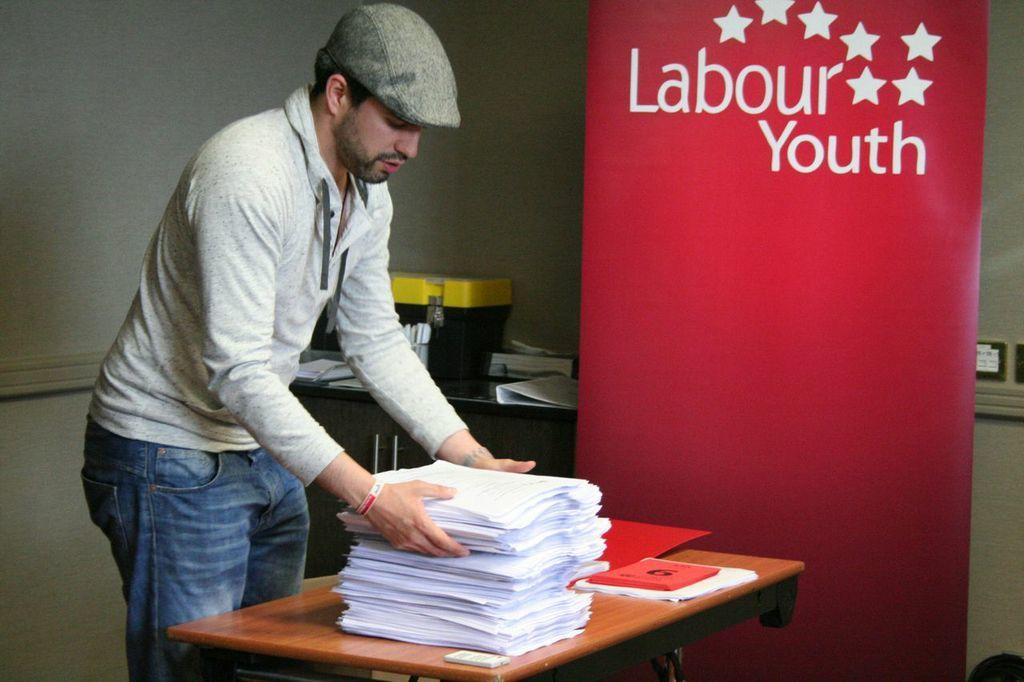What is the person in the image doing? The person is standing and holding papers in the image. What is the person wearing on their head? The person is wearing a cap. What is present on the table in the image? There is a table in the image, and on it, there are papers and a book. What can be seen in the background of the image? There is a wall and a banner in the background of the image, as well as things on the table in the background. Where is the tub located in the image? There is no tub present in the image. What type of bushes can be seen growing near the person in the image? There are no bushes visible in the image. 